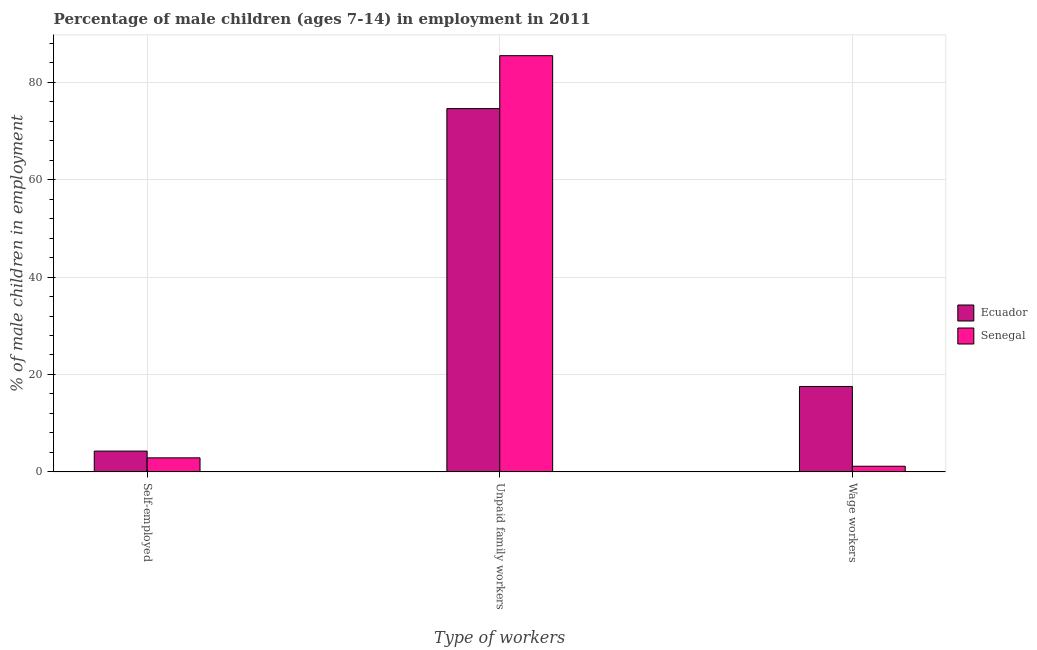How many bars are there on the 1st tick from the left?
Provide a short and direct response. 2. What is the label of the 2nd group of bars from the left?
Your answer should be compact. Unpaid family workers. What is the percentage of children employed as wage workers in Senegal?
Offer a terse response. 1.17. Across all countries, what is the maximum percentage of children employed as unpaid family workers?
Your answer should be compact. 85.43. Across all countries, what is the minimum percentage of children employed as unpaid family workers?
Ensure brevity in your answer.  74.57. In which country was the percentage of children employed as wage workers maximum?
Your answer should be very brief. Ecuador. In which country was the percentage of children employed as wage workers minimum?
Your answer should be compact. Senegal. What is the total percentage of children employed as unpaid family workers in the graph?
Make the answer very short. 160. What is the difference between the percentage of children employed as unpaid family workers in Ecuador and that in Senegal?
Make the answer very short. -10.86. What is the difference between the percentage of children employed as unpaid family workers in Senegal and the percentage of children employed as wage workers in Ecuador?
Keep it short and to the point. 67.89. What is the average percentage of children employed as wage workers per country?
Your answer should be compact. 9.36. What is the difference between the percentage of children employed as unpaid family workers and percentage of children employed as wage workers in Ecuador?
Your answer should be very brief. 57.03. In how many countries, is the percentage of self employed children greater than 68 %?
Ensure brevity in your answer.  0. What is the ratio of the percentage of children employed as wage workers in Senegal to that in Ecuador?
Provide a succinct answer. 0.07. Is the percentage of children employed as unpaid family workers in Ecuador less than that in Senegal?
Offer a terse response. Yes. What is the difference between the highest and the second highest percentage of self employed children?
Provide a short and direct response. 1.39. What is the difference between the highest and the lowest percentage of self employed children?
Make the answer very short. 1.39. Is the sum of the percentage of children employed as unpaid family workers in Senegal and Ecuador greater than the maximum percentage of children employed as wage workers across all countries?
Give a very brief answer. Yes. What does the 2nd bar from the left in Wage workers represents?
Ensure brevity in your answer.  Senegal. What does the 2nd bar from the right in Self-employed represents?
Ensure brevity in your answer.  Ecuador. How many bars are there?
Make the answer very short. 6. What is the difference between two consecutive major ticks on the Y-axis?
Offer a terse response. 20. Are the values on the major ticks of Y-axis written in scientific E-notation?
Your answer should be very brief. No. Does the graph contain any zero values?
Offer a terse response. No. How many legend labels are there?
Offer a terse response. 2. What is the title of the graph?
Provide a succinct answer. Percentage of male children (ages 7-14) in employment in 2011. Does "Maldives" appear as one of the legend labels in the graph?
Your answer should be compact. No. What is the label or title of the X-axis?
Your answer should be very brief. Type of workers. What is the label or title of the Y-axis?
Ensure brevity in your answer.  % of male children in employment. What is the % of male children in employment in Ecuador in Self-employed?
Your response must be concise. 4.28. What is the % of male children in employment of Senegal in Self-employed?
Offer a very short reply. 2.89. What is the % of male children in employment in Ecuador in Unpaid family workers?
Ensure brevity in your answer.  74.57. What is the % of male children in employment in Senegal in Unpaid family workers?
Keep it short and to the point. 85.43. What is the % of male children in employment of Ecuador in Wage workers?
Provide a short and direct response. 17.54. What is the % of male children in employment of Senegal in Wage workers?
Your response must be concise. 1.17. Across all Type of workers, what is the maximum % of male children in employment of Ecuador?
Provide a succinct answer. 74.57. Across all Type of workers, what is the maximum % of male children in employment in Senegal?
Offer a terse response. 85.43. Across all Type of workers, what is the minimum % of male children in employment of Ecuador?
Make the answer very short. 4.28. Across all Type of workers, what is the minimum % of male children in employment of Senegal?
Provide a short and direct response. 1.17. What is the total % of male children in employment of Ecuador in the graph?
Your response must be concise. 96.39. What is the total % of male children in employment of Senegal in the graph?
Provide a succinct answer. 89.49. What is the difference between the % of male children in employment of Ecuador in Self-employed and that in Unpaid family workers?
Provide a short and direct response. -70.29. What is the difference between the % of male children in employment of Senegal in Self-employed and that in Unpaid family workers?
Offer a terse response. -82.54. What is the difference between the % of male children in employment of Ecuador in Self-employed and that in Wage workers?
Offer a very short reply. -13.26. What is the difference between the % of male children in employment of Senegal in Self-employed and that in Wage workers?
Ensure brevity in your answer.  1.72. What is the difference between the % of male children in employment of Ecuador in Unpaid family workers and that in Wage workers?
Offer a very short reply. 57.03. What is the difference between the % of male children in employment in Senegal in Unpaid family workers and that in Wage workers?
Your answer should be compact. 84.26. What is the difference between the % of male children in employment of Ecuador in Self-employed and the % of male children in employment of Senegal in Unpaid family workers?
Offer a very short reply. -81.15. What is the difference between the % of male children in employment in Ecuador in Self-employed and the % of male children in employment in Senegal in Wage workers?
Provide a short and direct response. 3.11. What is the difference between the % of male children in employment in Ecuador in Unpaid family workers and the % of male children in employment in Senegal in Wage workers?
Your response must be concise. 73.4. What is the average % of male children in employment of Ecuador per Type of workers?
Your answer should be very brief. 32.13. What is the average % of male children in employment in Senegal per Type of workers?
Provide a short and direct response. 29.83. What is the difference between the % of male children in employment of Ecuador and % of male children in employment of Senegal in Self-employed?
Provide a short and direct response. 1.39. What is the difference between the % of male children in employment in Ecuador and % of male children in employment in Senegal in Unpaid family workers?
Offer a terse response. -10.86. What is the difference between the % of male children in employment of Ecuador and % of male children in employment of Senegal in Wage workers?
Offer a terse response. 16.37. What is the ratio of the % of male children in employment of Ecuador in Self-employed to that in Unpaid family workers?
Keep it short and to the point. 0.06. What is the ratio of the % of male children in employment in Senegal in Self-employed to that in Unpaid family workers?
Your response must be concise. 0.03. What is the ratio of the % of male children in employment of Ecuador in Self-employed to that in Wage workers?
Your answer should be very brief. 0.24. What is the ratio of the % of male children in employment of Senegal in Self-employed to that in Wage workers?
Make the answer very short. 2.47. What is the ratio of the % of male children in employment in Ecuador in Unpaid family workers to that in Wage workers?
Provide a succinct answer. 4.25. What is the ratio of the % of male children in employment of Senegal in Unpaid family workers to that in Wage workers?
Make the answer very short. 73.02. What is the difference between the highest and the second highest % of male children in employment in Ecuador?
Your answer should be compact. 57.03. What is the difference between the highest and the second highest % of male children in employment in Senegal?
Your response must be concise. 82.54. What is the difference between the highest and the lowest % of male children in employment in Ecuador?
Ensure brevity in your answer.  70.29. What is the difference between the highest and the lowest % of male children in employment of Senegal?
Keep it short and to the point. 84.26. 